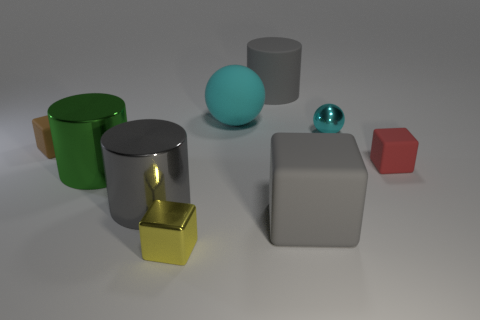There is a matte object that is the same color as the small ball; what size is it?
Give a very brief answer. Large. What number of tiny shiny things are the same color as the rubber sphere?
Your response must be concise. 1. Does the large sphere have the same color as the tiny metallic object behind the small yellow thing?
Give a very brief answer. Yes. What is the shape of the small metal thing that is the same color as the big sphere?
Provide a succinct answer. Sphere. Are there any objects that have the same color as the metal ball?
Offer a very short reply. Yes. What number of objects are large purple shiny balls or balls?
Give a very brief answer. 2. There is a metal object behind the small brown rubber thing; what is its size?
Keep it short and to the point. Small. What number of other objects are there of the same material as the red block?
Make the answer very short. 4. Are there any tiny rubber objects behind the large gray cylinder in front of the cyan matte ball?
Give a very brief answer. Yes. There is a rubber object that is the same shape as the tiny cyan metal thing; what color is it?
Offer a very short reply. Cyan. 